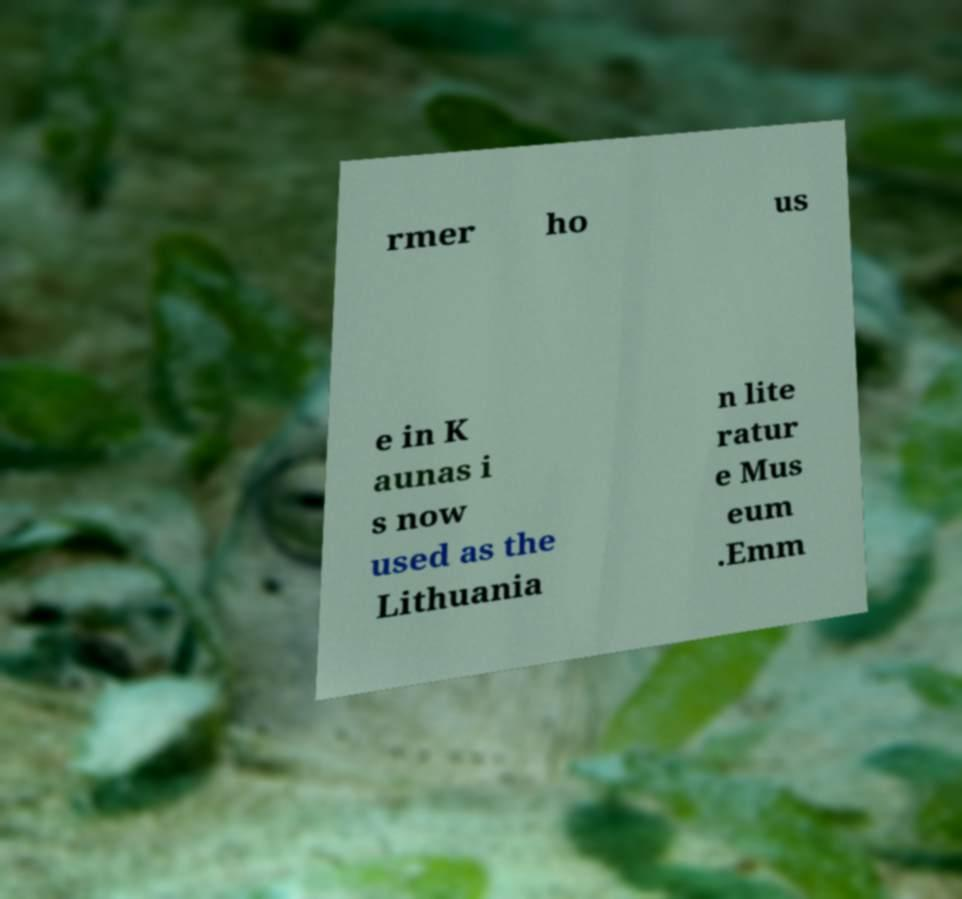For documentation purposes, I need the text within this image transcribed. Could you provide that? rmer ho us e in K aunas i s now used as the Lithuania n lite ratur e Mus eum .Emm 